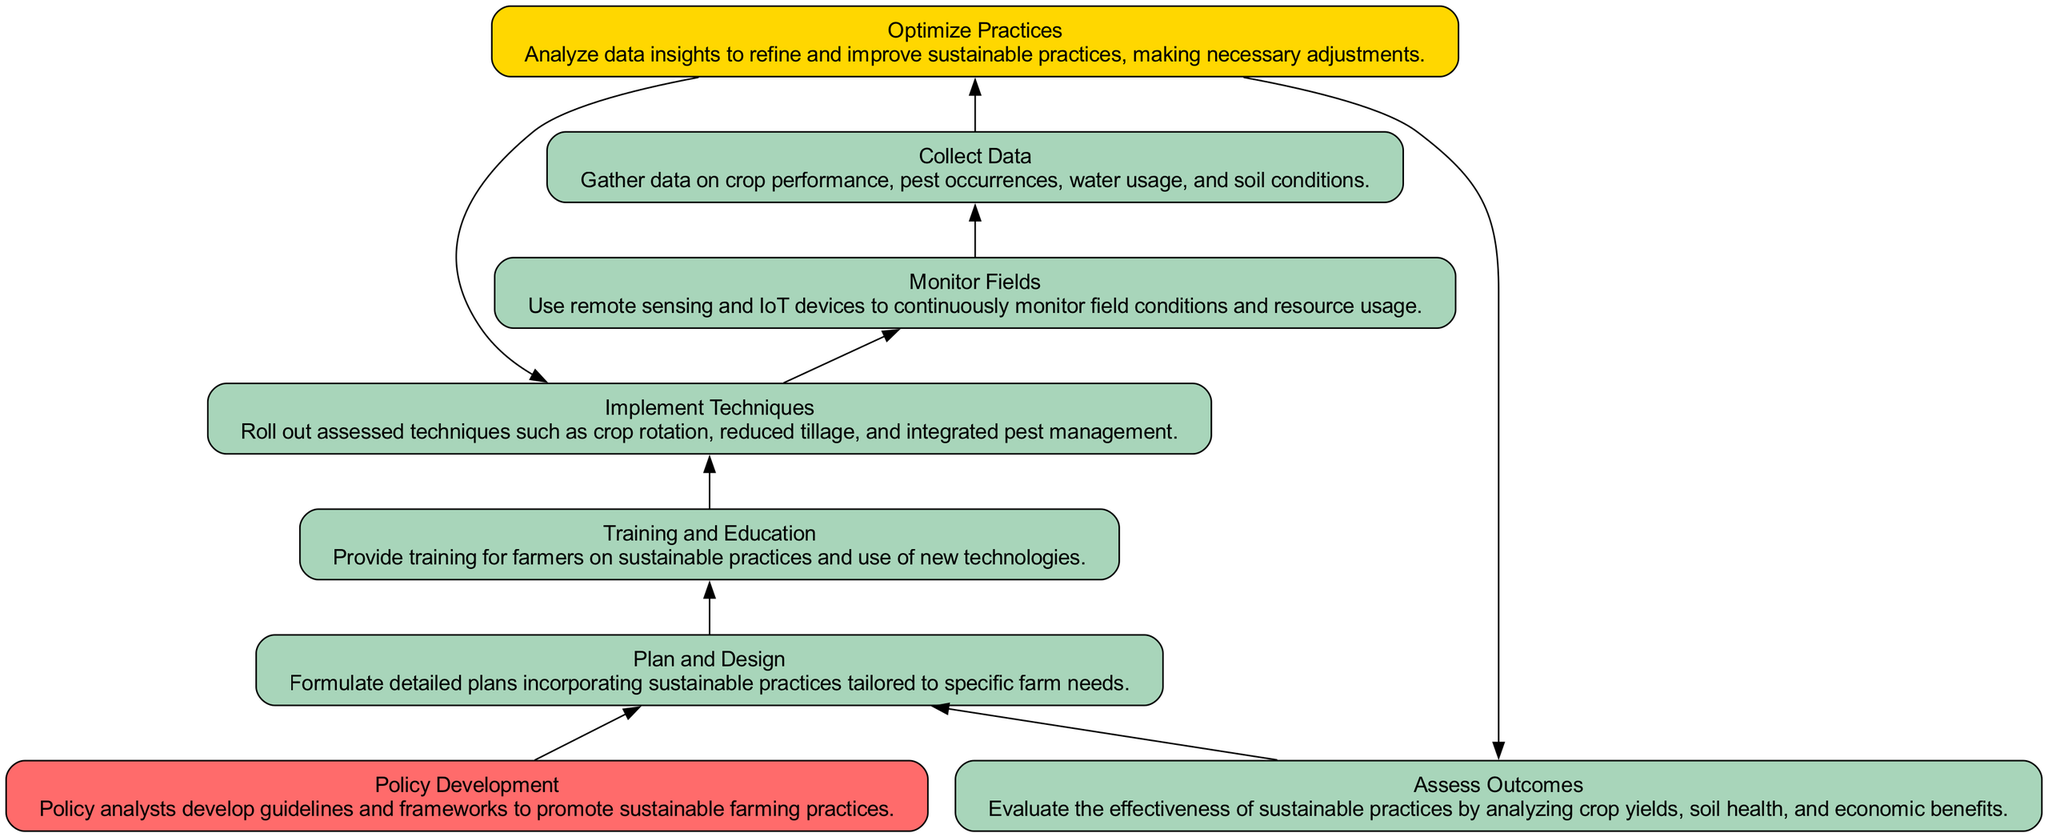What is the starting point of the flowchart? The starting point of the flowchart is represented by node "8," which is labeled "Policy Development." This node signifies the beginning of the process regarding the implementation of sustainable farming practices.
Answer: Policy Development How many process nodes are there in the diagram? The diagram contains six process nodes: "Assess Outcomes," "Collect Data," "Monitor Fields," "Implement Techniques," "Training and Education," and "Plan and Design." By counting each process node in the elements section, we identify them.
Answer: Six Which node follows "Training and Education"? In the flowchart, "Training and Education" (node 6) is followed by "Implement Techniques" (node 5). This is based on the directed edges that establish the flow from one node to the next.
Answer: Implement Techniques What is the color of the "Decision" type node? The "Decision" type node, which is "Optimize Practices" (node 4), is colored gold according to the defined color palette for the diagram. Each node type has a specific color, and decisions are labeled with a yellow shade.
Answer: Gold What is the relationship between "Collect Data" and "Monitor Fields"? "Collect Data" (node 2) feeds into "Optimize Practices" (node 4) after "Monitor Fields" (node 3) gathers information. The flow shows that data collection occurs before or during field monitoring, thus connecting these two processes sequentially.
Answer: Through Optimize Practices Which node evaluates the effectiveness of sustainable practices? The node "Assess Outcomes" (node 1) is responsible for evaluating the effectiveness of sustainable practices by analyzing various outcomes such as crop yields and soil health, as indicated in the diagram.
Answer: Assess Outcomes What happens after "Optimize Practices"? Following "Optimize Practices" (node 4), the next steps bifurcate into either "Assess Outcomes" (node 1) or "Implement Techniques" (node 5). This decision-making point indicates the two possible paths leading to either assessing or putting practices into action.
Answer: Assess Outcomes and Implement Techniques What is the final step in the process? The final step in the flowchart is "Assess Outcomes," which evaluates the effectiveness and results of the sustainably implemented practices. This is the endpoint after multiple processes have been completed.
Answer: Assess Outcomes 